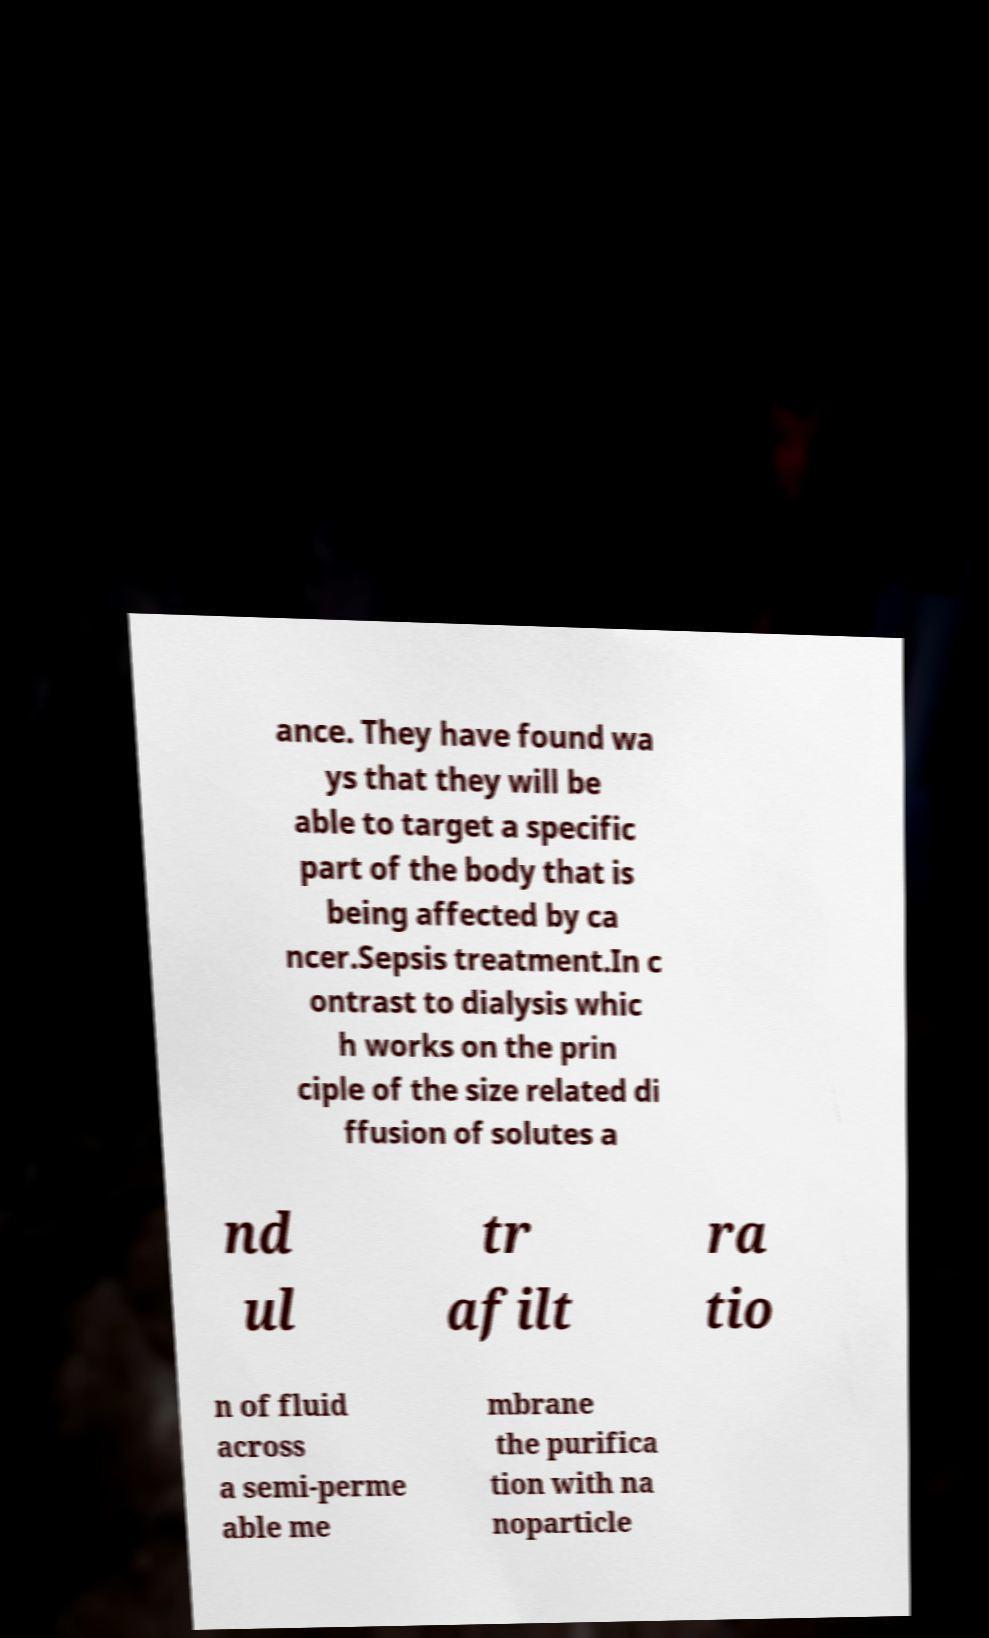Could you assist in decoding the text presented in this image and type it out clearly? ance. They have found wa ys that they will be able to target a specific part of the body that is being affected by ca ncer.Sepsis treatment.In c ontrast to dialysis whic h works on the prin ciple of the size related di ffusion of solutes a nd ul tr afilt ra tio n of fluid across a semi-perme able me mbrane the purifica tion with na noparticle 